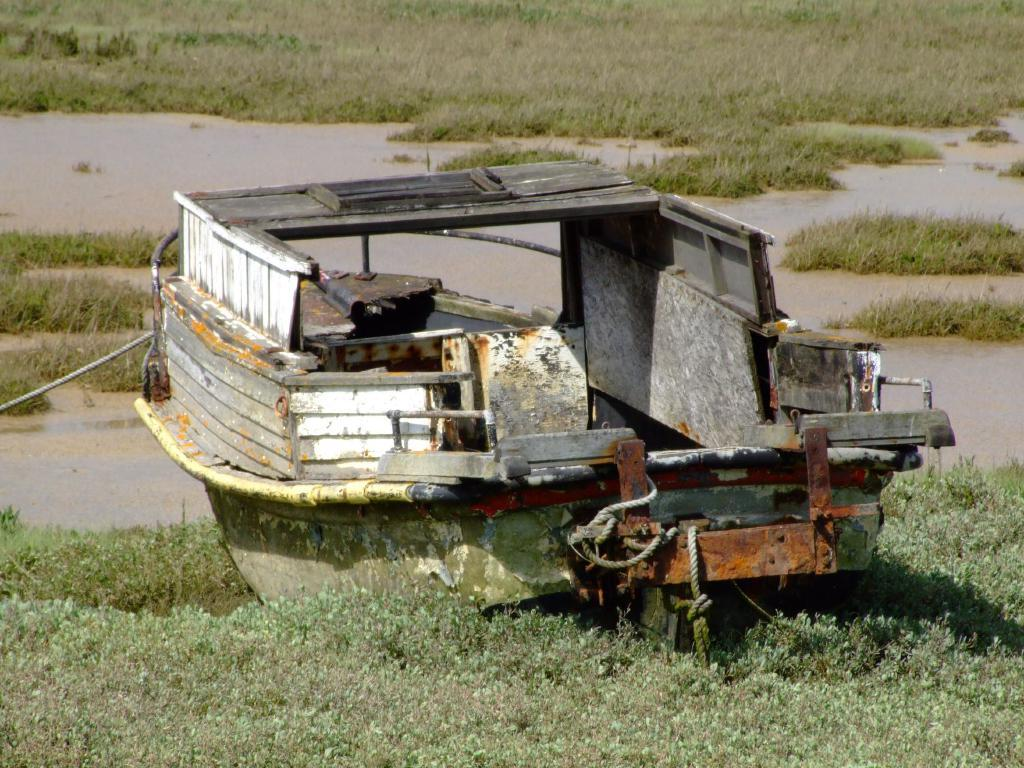What is the main subject of the image? The main subject of the image is a boat. What feature can be seen on the boat? The boat has ropes. Where is the boat located in the image? The boat is placed on the ground. What can be seen in the background of the image? There is water visible in the background of the image. What type of button can be seen on the nose of the secretary in the image? There is no secretary or button present in the image; it features a boat with ropes on the ground and water visible in the background. 